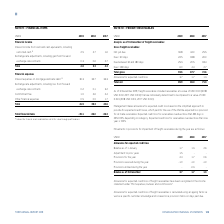According to Torm's financial document, As of 2019, what did freight receivables include? receivables at a value of USD 0.0m (2018: USD 0.0m 2017: USD 0.0m) that are individually determined to be impaired to a value of USD 0.0m (2018: USD 0.0m, 2017: USD 0.0m). The document states: "of 31 December 2019, freight receivables included receivables at a value of USD 0.0m (2018: USD 0.0m 2017: USD 0.0m) that are individually determined ..." Also, What is the making of allowance for expected credit loss based on? the simplified approach to provide for expected credit losses, which permits the use of the lifetime expected loss provision for all trade receivables. The document states: "makes allowance for expected credit loss based on the simplified approach to provide for expected credit losses, which permits the use of the lifetime..." Also, For which years were the gross freight receivables recorded in? The document contains multiple relevant values: 2019, 2018, 2017. From the document: "USDm 2019 2018 2017 USDm 2019 2018 2017 USDm 2019 2018 2017..." Additionally, In which year was the amount of total gross freight receivables the largest? According to the financial document, 2019. The relevant text states: "USDm 2019 2018 2017..." Also, can you calculate: What was the change in the total net gross freight receivables in 2019 from 2018? Based on the calculation: 89.9-86.0, the result is 3.9 (in millions). This is based on the information: "Total net 89.9 86.0 71.3 Total net 89.9 86.0 71.3..." The key data points involved are: 86.0, 89.9. Also, can you calculate: What was the percentage change in the total net gross freight receivables in 2019 from 2018? To answer this question, I need to perform calculations using the financial data. The calculation is: (89.9-86.0)/86.0, which equals 4.53 (percentage). This is based on the information: "Total net 89.9 86.0 71.3 Total net 89.9 86.0 71.3..." The key data points involved are: 86.0, 89.9. 